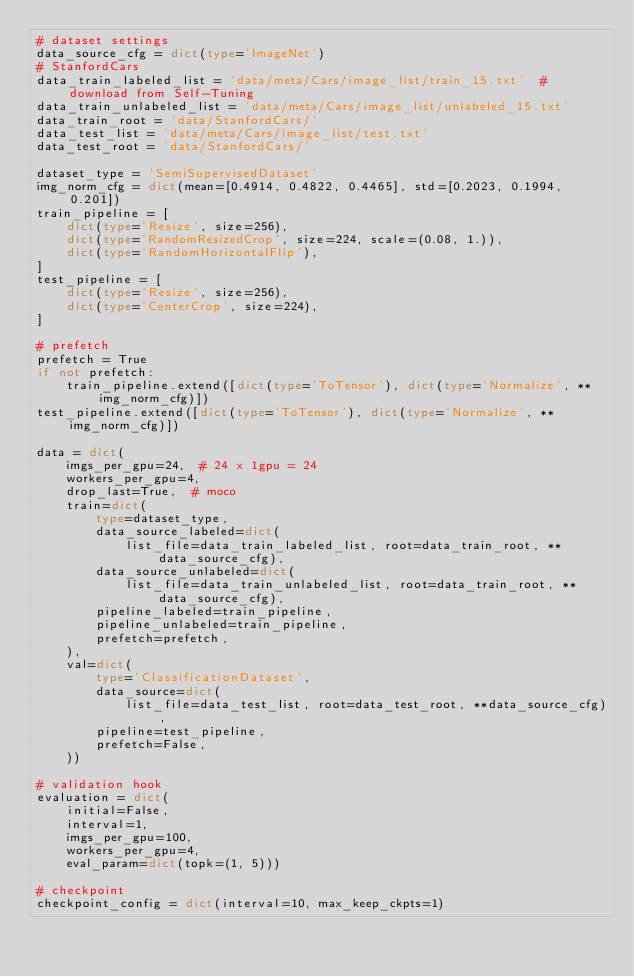<code> <loc_0><loc_0><loc_500><loc_500><_Python_># dataset settings
data_source_cfg = dict(type='ImageNet')
# StanfordCars
data_train_labeled_list = 'data/meta/Cars/image_list/train_15.txt'  # download from Self-Tuning
data_train_unlabeled_list = 'data/meta/Cars/image_list/unlabeled_15.txt'
data_train_root = 'data/StanfordCars/'
data_test_list = 'data/meta/Cars/image_list/test.txt'
data_test_root = 'data/StanfordCars/'

dataset_type = 'SemiSupervisedDataset'
img_norm_cfg = dict(mean=[0.4914, 0.4822, 0.4465], std=[0.2023, 0.1994, 0.201])
train_pipeline = [
    dict(type='Resize', size=256),
    dict(type='RandomResizedCrop', size=224, scale=(0.08, 1.)),
    dict(type='RandomHorizontalFlip'),
]
test_pipeline = [
    dict(type='Resize', size=256),
    dict(type='CenterCrop', size=224),
]

# prefetch
prefetch = True
if not prefetch:
    train_pipeline.extend([dict(type='ToTensor'), dict(type='Normalize', **img_norm_cfg)])
test_pipeline.extend([dict(type='ToTensor'), dict(type='Normalize', **img_norm_cfg)])

data = dict(
    imgs_per_gpu=24,  # 24 x 1gpu = 24
    workers_per_gpu=4,
    drop_last=True,  # moco
    train=dict(
        type=dataset_type,
        data_source_labeled=dict(
            list_file=data_train_labeled_list, root=data_train_root, **data_source_cfg),
        data_source_unlabeled=dict(
            list_file=data_train_unlabeled_list, root=data_train_root, **data_source_cfg),
        pipeline_labeled=train_pipeline,
        pipeline_unlabeled=train_pipeline,
        prefetch=prefetch,
    ),
    val=dict(
        type='ClassificationDataset',
        data_source=dict(
            list_file=data_test_list, root=data_test_root, **data_source_cfg),
        pipeline=test_pipeline,
        prefetch=False,
    ))

# validation hook
evaluation = dict(
    initial=False,
    interval=1,
    imgs_per_gpu=100,
    workers_per_gpu=4,
    eval_param=dict(topk=(1, 5)))

# checkpoint
checkpoint_config = dict(interval=10, max_keep_ckpts=1)
</code> 